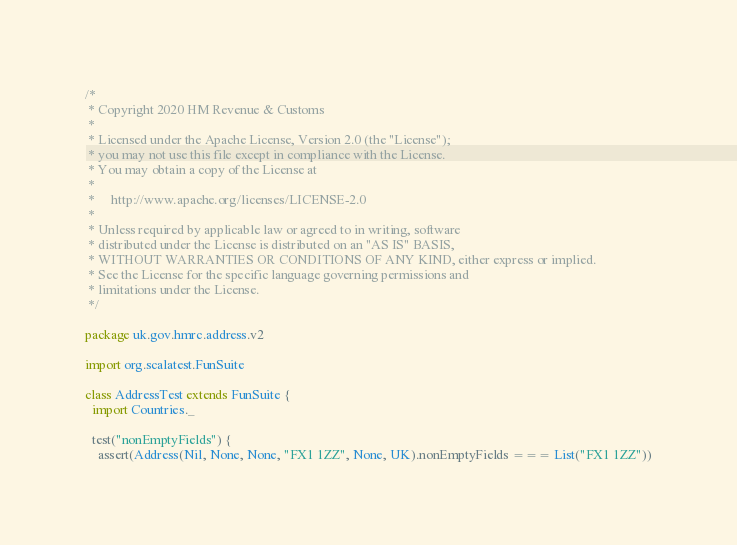<code> <loc_0><loc_0><loc_500><loc_500><_Scala_>/*
 * Copyright 2020 HM Revenue & Customs
 *
 * Licensed under the Apache License, Version 2.0 (the "License");
 * you may not use this file except in compliance with the License.
 * You may obtain a copy of the License at
 *
 *     http://www.apache.org/licenses/LICENSE-2.0
 *
 * Unless required by applicable law or agreed to in writing, software
 * distributed under the License is distributed on an "AS IS" BASIS,
 * WITHOUT WARRANTIES OR CONDITIONS OF ANY KIND, either express or implied.
 * See the License for the specific language governing permissions and
 * limitations under the License.
 */

package uk.gov.hmrc.address.v2

import org.scalatest.FunSuite

class AddressTest extends FunSuite {
  import Countries._

  test("nonEmptyFields") {
    assert(Address(Nil, None, None, "FX1 1ZZ", None, UK).nonEmptyFields === List("FX1 1ZZ"))
</code> 